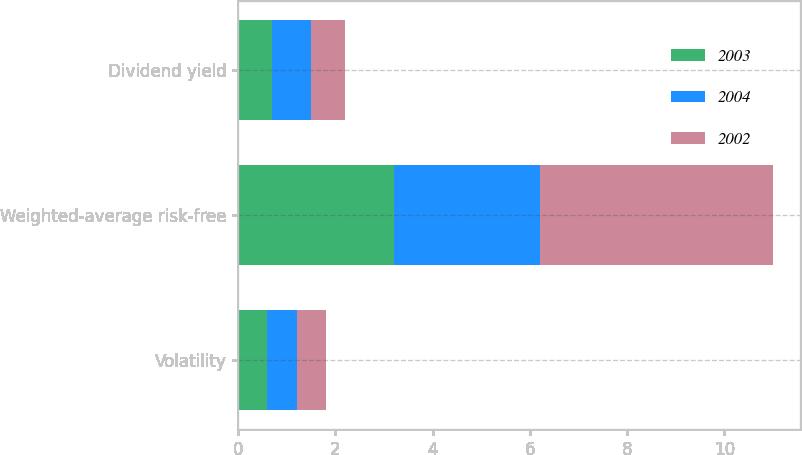Convert chart to OTSL. <chart><loc_0><loc_0><loc_500><loc_500><stacked_bar_chart><ecel><fcel>Volatility<fcel>Weighted-average risk-free<fcel>Dividend yield<nl><fcel>2003<fcel>0.6<fcel>3.2<fcel>0.7<nl><fcel>2004<fcel>0.6<fcel>3<fcel>0.8<nl><fcel>2002<fcel>0.6<fcel>4.8<fcel>0.7<nl></chart> 